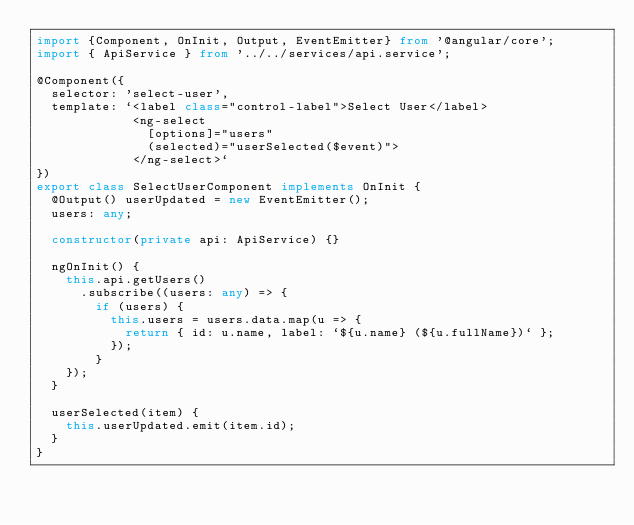<code> <loc_0><loc_0><loc_500><loc_500><_TypeScript_>import {Component, OnInit, Output, EventEmitter} from '@angular/core';
import { ApiService } from '../../services/api.service';

@Component({
  selector: 'select-user',
  template: `<label class="control-label">Select User</label>
             <ng-select
               [options]="users"
               (selected)="userSelected($event)">
             </ng-select>`
})
export class SelectUserComponent implements OnInit {
  @Output() userUpdated = new EventEmitter();
  users: any;

  constructor(private api: ApiService) {}

  ngOnInit() {
    this.api.getUsers()
      .subscribe((users: any) => {
        if (users) {
          this.users = users.data.map(u => {
            return { id: u.name, label: `${u.name} (${u.fullName})` };
          });
        }
    });
  }

  userSelected(item) {
    this.userUpdated.emit(item.id);
  }
}
</code> 